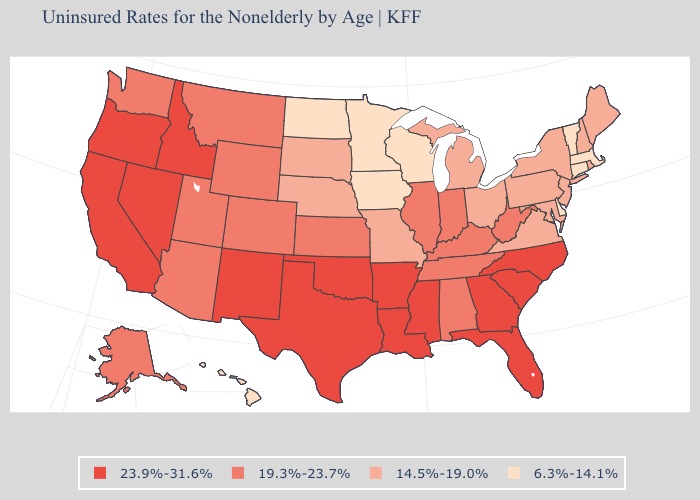Among the states that border South Dakota , which have the highest value?
Keep it brief. Montana, Wyoming. Does the first symbol in the legend represent the smallest category?
Keep it brief. No. Name the states that have a value in the range 19.3%-23.7%?
Be succinct. Alabama, Alaska, Arizona, Colorado, Illinois, Indiana, Kansas, Kentucky, Montana, Tennessee, Utah, Washington, West Virginia, Wyoming. How many symbols are there in the legend?
Answer briefly. 4. Among the states that border Texas , which have the lowest value?
Give a very brief answer. Arkansas, Louisiana, New Mexico, Oklahoma. What is the lowest value in states that border North Carolina?
Quick response, please. 14.5%-19.0%. Name the states that have a value in the range 19.3%-23.7%?
Give a very brief answer. Alabama, Alaska, Arizona, Colorado, Illinois, Indiana, Kansas, Kentucky, Montana, Tennessee, Utah, Washington, West Virginia, Wyoming. What is the lowest value in states that border Nebraska?
Short answer required. 6.3%-14.1%. What is the value of Minnesota?
Short answer required. 6.3%-14.1%. What is the value of Alaska?
Give a very brief answer. 19.3%-23.7%. Does Massachusetts have the highest value in the Northeast?
Give a very brief answer. No. How many symbols are there in the legend?
Keep it brief. 4. Does Oregon have the highest value in the USA?
Quick response, please. Yes. What is the lowest value in states that border Wisconsin?
Keep it brief. 6.3%-14.1%. Among the states that border California , does Arizona have the highest value?
Short answer required. No. 